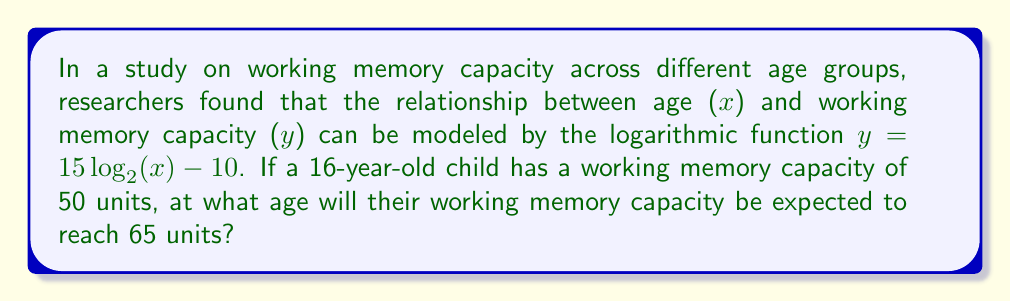Show me your answer to this math problem. To solve this problem, we'll follow these steps:

1. Given function: $y = 15 \log_2(x) - 10$
   Where y is working memory capacity and x is age.

2. We need to find x when y = 65:
   $65 = 15 \log_2(x) - 10$

3. Isolate the logarithmic term:
   $65 + 10 = 15 \log_2(x)$
   $75 = 15 \log_2(x)$

4. Divide both sides by 15:
   $\frac{75}{15} = \log_2(x)$
   $5 = \log_2(x)$

5. To solve for x, we need to apply the inverse function (exponential):
   $2^5 = x$
   $32 = x$

Therefore, the working memory capacity is expected to reach 65 units at age 32.

6. To verify, we can plug the age of 16 into the original equation:
   $y = 15 \log_2(16) - 10$
   $y = 15 * 4 - 10 = 50$

This confirms that the function correctly predicts a working memory capacity of 50 units for a 16-year-old.
Answer: 32 years old 